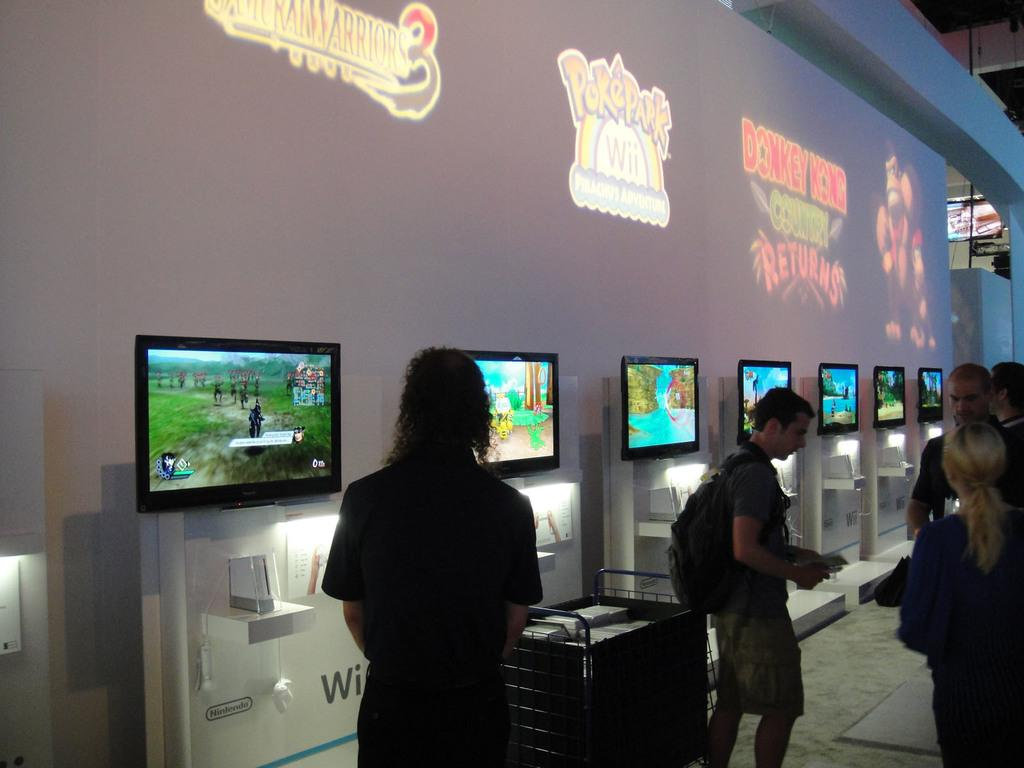Who or what can be seen in the foreground of the image? There are people in the foreground of the image. What electronic devices are present in the image? There are televisions in the image. What can be seen in the background of the image? There are posters or other objects in the background of the image. How many babies are crawling on the branch in the image? There are no babies or branches present in the image. 